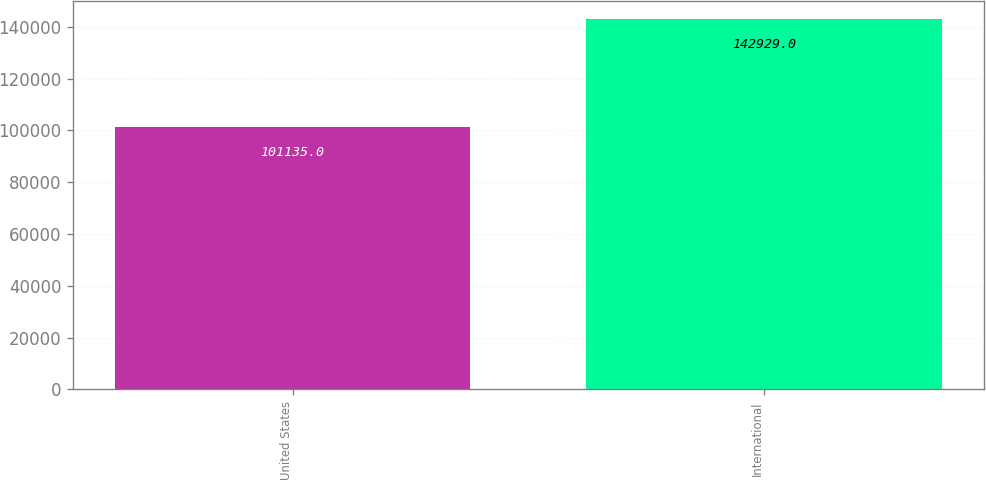Convert chart to OTSL. <chart><loc_0><loc_0><loc_500><loc_500><bar_chart><fcel>United States<fcel>International<nl><fcel>101135<fcel>142929<nl></chart> 